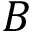<formula> <loc_0><loc_0><loc_500><loc_500>B</formula> 